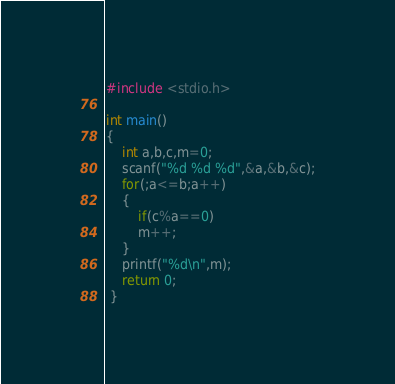<code> <loc_0><loc_0><loc_500><loc_500><_C_>#include <stdio.h>

int main()
{
	int a,b,c,m=0;
	scanf("%d %d %d",&a,&b,&c);
	for(;a<=b;a++)
	{
		if(c%a==0)
		m++;
	}
	printf("%d\n",m);
	return 0;
 } 
</code> 